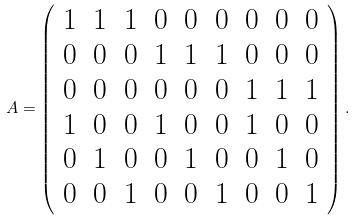<formula> <loc_0><loc_0><loc_500><loc_500>A = \left ( \begin{array} { c c c c c c c c c } 1 & 1 & 1 & 0 & 0 & 0 & 0 & 0 & 0 \\ 0 & 0 & 0 & 1 & 1 & 1 & 0 & 0 & 0 \\ 0 & 0 & 0 & 0 & 0 & 0 & 1 & 1 & 1 \\ 1 & 0 & 0 & 1 & 0 & 0 & 1 & 0 & 0 \\ 0 & 1 & 0 & 0 & 1 & 0 & 0 & 1 & 0 \\ 0 & 0 & 1 & 0 & 0 & 1 & 0 & 0 & 1 \end{array} \right ) .</formula> 